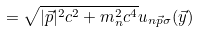<formula> <loc_0><loc_0><loc_500><loc_500>= \sqrt { | \vec { p } | ^ { 2 } c ^ { 2 } + m _ { n } ^ { 2 } c ^ { 4 } } u _ { n \vec { p } \sigma } ( \vec { y } )</formula> 